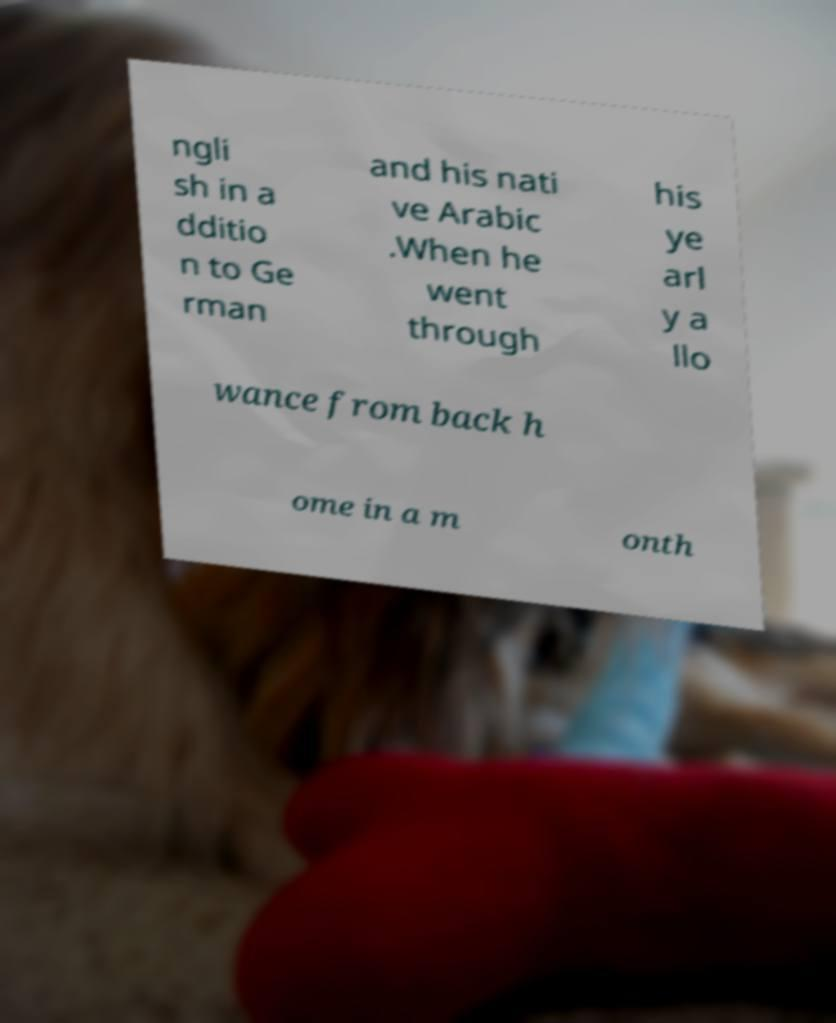Can you read and provide the text displayed in the image?This photo seems to have some interesting text. Can you extract and type it out for me? ngli sh in a dditio n to Ge rman and his nati ve Arabic .When he went through his ye arl y a llo wance from back h ome in a m onth 